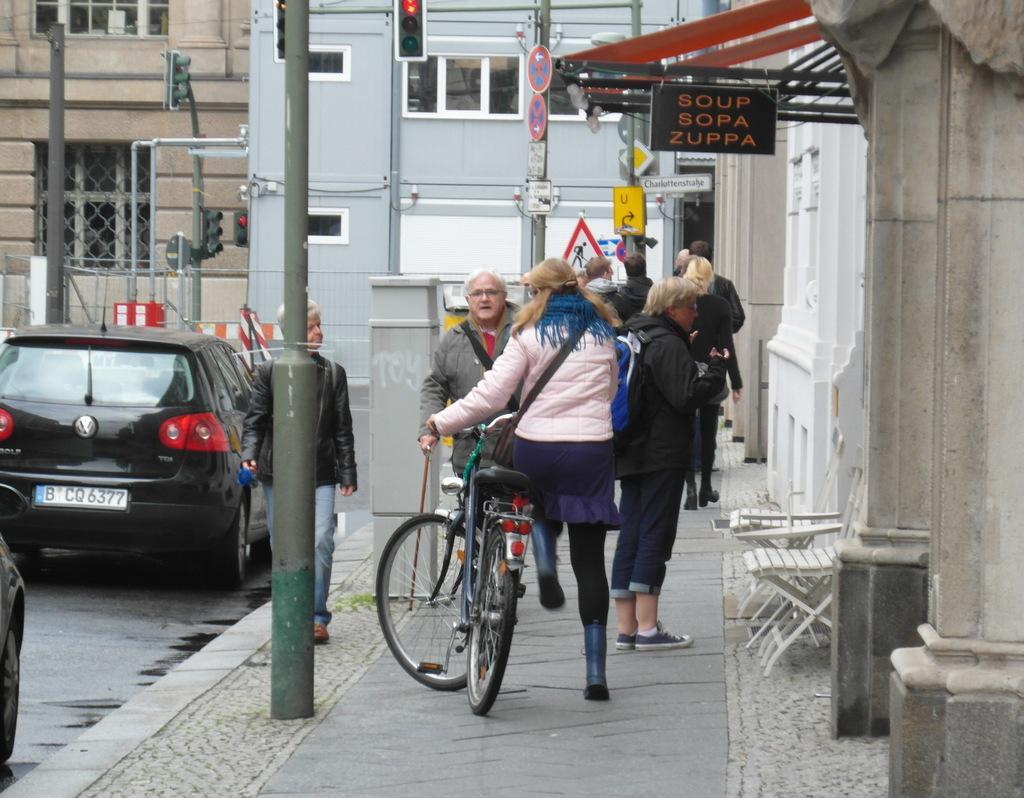How would you summarize this image in a sentence or two? people are walking on a walk way. a person is holding a bicycle. at the left there are cars on the road. at the right there is a building and chairs. above that soup sopa zuppa named shop is present. at the back there are buildings. 